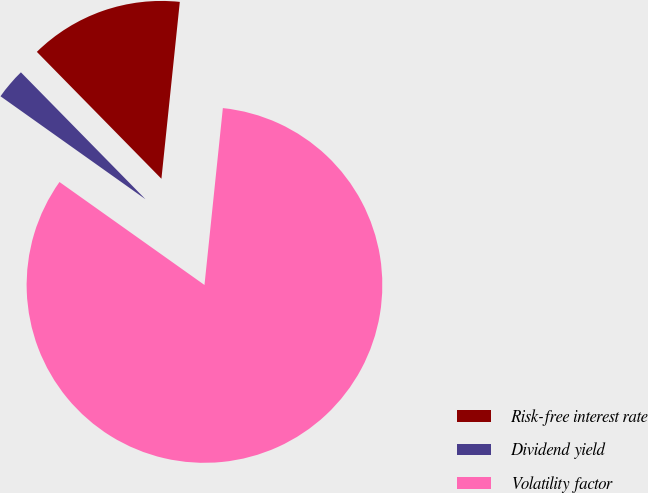Convert chart. <chart><loc_0><loc_0><loc_500><loc_500><pie_chart><fcel>Risk-free interest rate<fcel>Dividend yield<fcel>Volatility factor<nl><fcel>14.0%<fcel>2.82%<fcel>83.18%<nl></chart> 